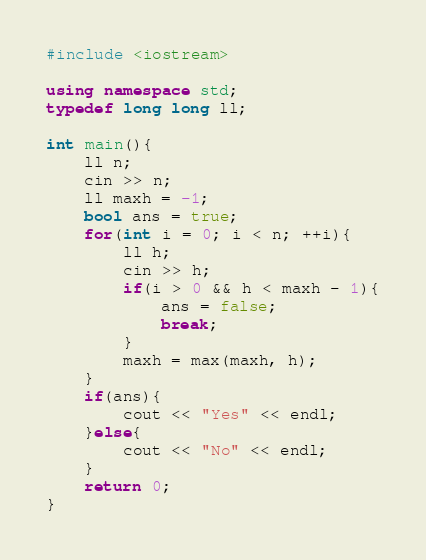Convert code to text. <code><loc_0><loc_0><loc_500><loc_500><_C++_>#include <iostream>

using namespace std;
typedef long long ll;

int main(){
    ll n;
    cin >> n;
    ll maxh = -1;
    bool ans = true;
    for(int i = 0; i < n; ++i){
        ll h;
        cin >> h;
        if(i > 0 && h < maxh - 1){
            ans = false;
            break;
        }
        maxh = max(maxh, h);
    }
    if(ans){
        cout << "Yes" << endl;
    }else{
        cout << "No" << endl;
    }
    return 0;
}
</code> 